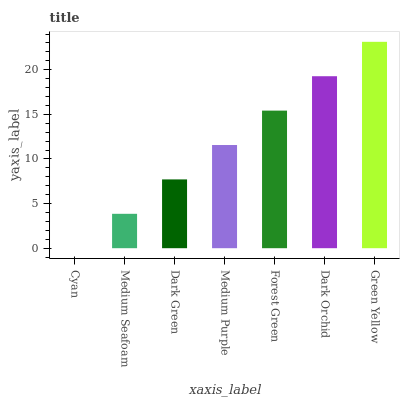Is Cyan the minimum?
Answer yes or no. Yes. Is Green Yellow the maximum?
Answer yes or no. Yes. Is Medium Seafoam the minimum?
Answer yes or no. No. Is Medium Seafoam the maximum?
Answer yes or no. No. Is Medium Seafoam greater than Cyan?
Answer yes or no. Yes. Is Cyan less than Medium Seafoam?
Answer yes or no. Yes. Is Cyan greater than Medium Seafoam?
Answer yes or no. No. Is Medium Seafoam less than Cyan?
Answer yes or no. No. Is Medium Purple the high median?
Answer yes or no. Yes. Is Medium Purple the low median?
Answer yes or no. Yes. Is Cyan the high median?
Answer yes or no. No. Is Forest Green the low median?
Answer yes or no. No. 